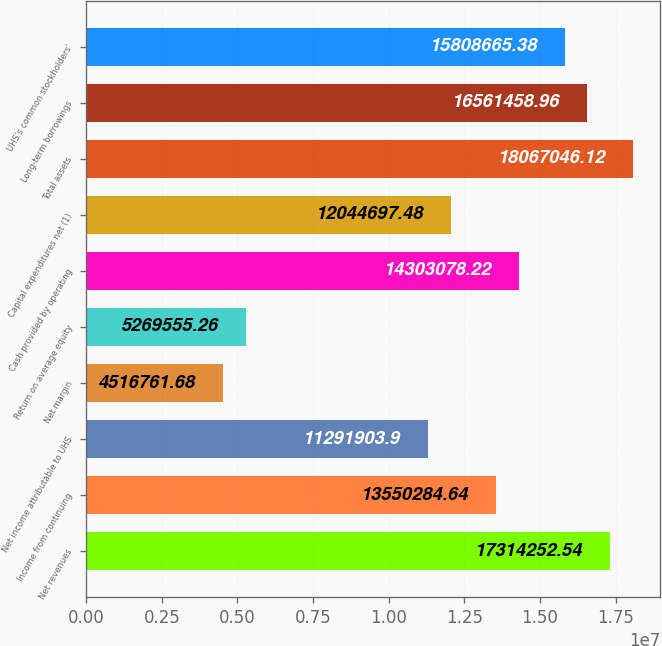Convert chart. <chart><loc_0><loc_0><loc_500><loc_500><bar_chart><fcel>Net revenues<fcel>Income from continuing<fcel>Net income attributable to UHS<fcel>Net margin<fcel>Return on average equity<fcel>Cash provided by operating<fcel>Capital expenditures net (1)<fcel>Total assets<fcel>Long-term borrowings<fcel>UHS's common stockholders'<nl><fcel>1.73143e+07<fcel>1.35503e+07<fcel>1.12919e+07<fcel>4.51676e+06<fcel>5.26956e+06<fcel>1.43031e+07<fcel>1.20447e+07<fcel>1.8067e+07<fcel>1.65615e+07<fcel>1.58087e+07<nl></chart> 